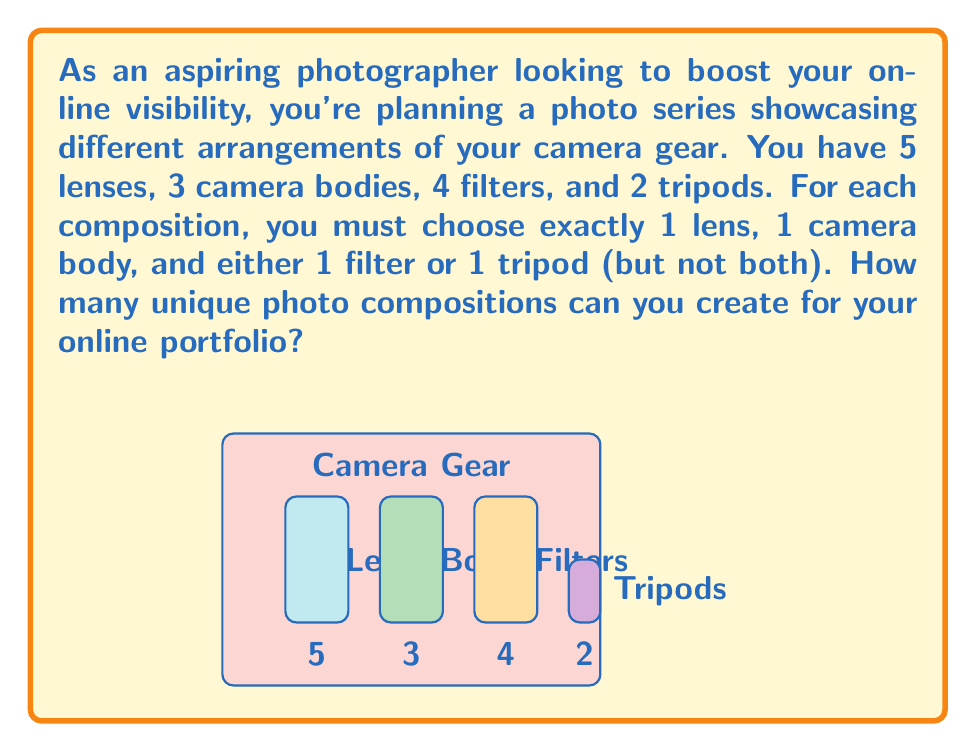Help me with this question. Let's approach this step-by-step using the multiplication principle of combinatorics:

1) First, we need to choose a lens. There are 5 lenses to choose from:
   $n_1 = 5$

2) Then, we need to choose a camera body. There are 3 camera bodies:
   $n_2 = 3$

3) For the last item, we have two mutually exclusive options:
   a) Choose a filter (4 options)
   b) Choose a tripod (2 options)
   The total number of ways to make this last choice is the sum of these options:
   $n_3 = 4 + 2 = 6$

4) According to the multiplication principle, if we have $n_1$ ways of doing something, $n_2$ ways of doing another thing, and $n_3$ ways of doing a third thing, then there are $n_1 \times n_2 \times n_3$ ways to do all three things.

5) Therefore, the total number of unique compositions is:

   $$5 \times 3 \times 6 = 90$$

This calculation gives us the total number of unique ways to arrange one lens, one camera body, and either one filter or one tripod.
Answer: 90 unique compositions 